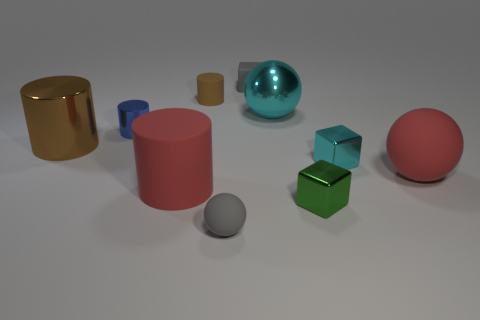Subtract all spheres. How many objects are left? 7 Add 2 tiny cyan things. How many tiny cyan things are left? 3 Add 9 yellow rubber objects. How many yellow rubber objects exist? 9 Subtract 0 blue cubes. How many objects are left? 10 Subtract all large brown cylinders. Subtract all tiny cyan matte things. How many objects are left? 9 